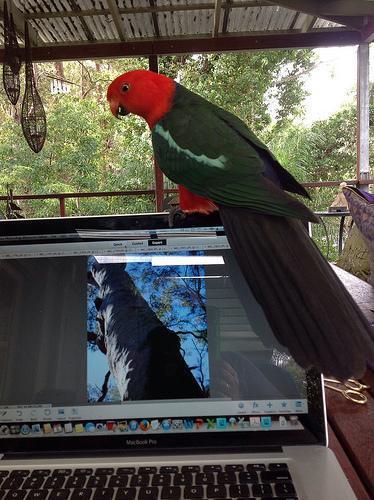How many birds?
Give a very brief answer. 1. 